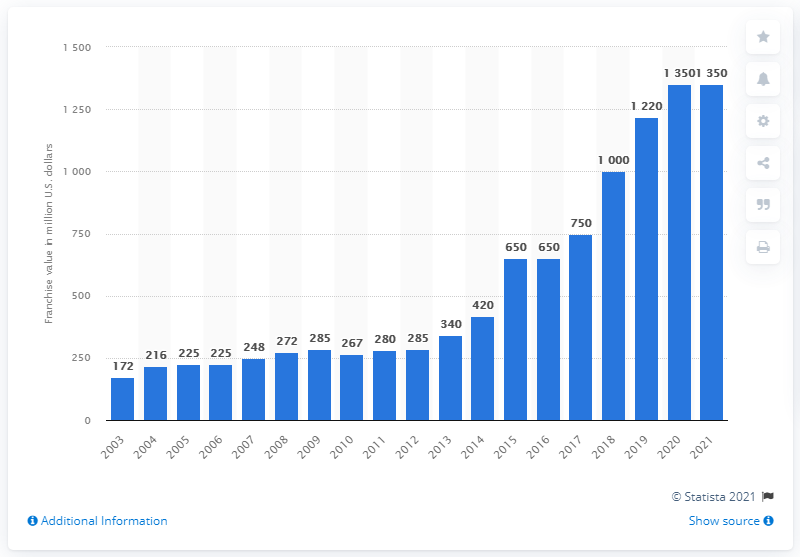List a handful of essential elements in this visual. The estimated value of the New Orleans Pelicans in 2021 was $1,350 million. 